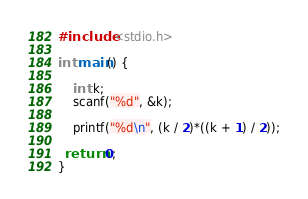Convert code to text. <code><loc_0><loc_0><loc_500><loc_500><_C_>#include <stdio.h>

int main() {
	
    int k;
	scanf("%d", &k);
	
	printf("%d\n", (k / 2)*((k + 1) / 2));
	
  return 0;
}
</code> 